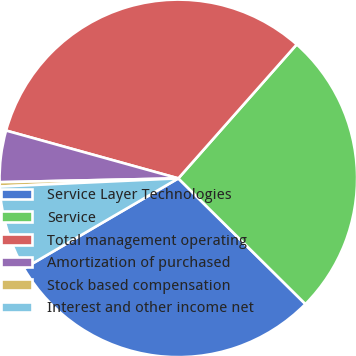<chart> <loc_0><loc_0><loc_500><loc_500><pie_chart><fcel>Service Layer Technologies<fcel>Service<fcel>Total management operating<fcel>Amortization of purchased<fcel>Stock based compensation<fcel>Interest and other income net<nl><fcel>29.18%<fcel>25.89%<fcel>32.21%<fcel>4.65%<fcel>0.39%<fcel>7.68%<nl></chart> 